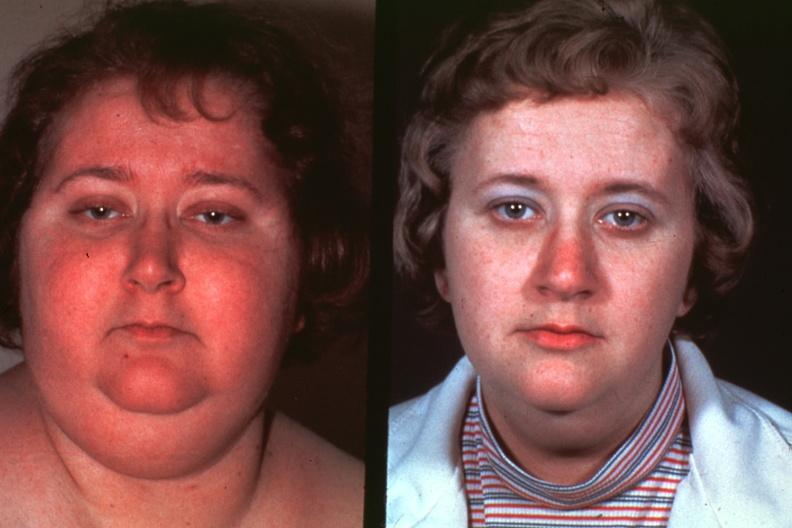s cushings disease present?
Answer the question using a single word or phrase. Yes 